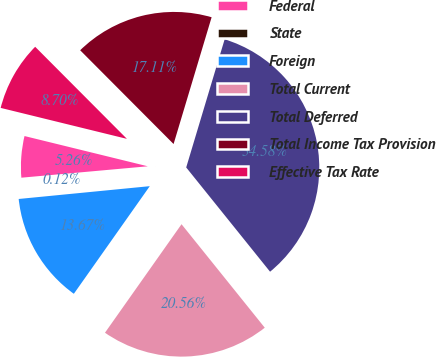Convert chart. <chart><loc_0><loc_0><loc_500><loc_500><pie_chart><fcel>Federal<fcel>State<fcel>Foreign<fcel>Total Current<fcel>Total Deferred<fcel>Total Income Tax Provision<fcel>Effective Tax Rate<nl><fcel>5.26%<fcel>0.12%<fcel>13.67%<fcel>20.56%<fcel>34.58%<fcel>17.11%<fcel>8.7%<nl></chart> 